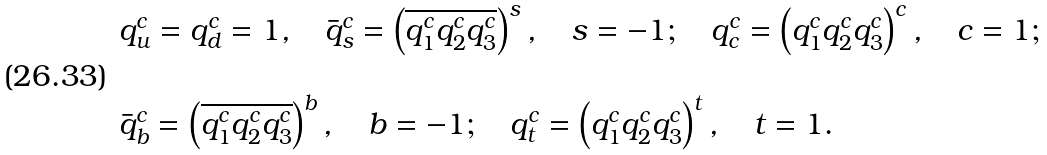<formula> <loc_0><loc_0><loc_500><loc_500>\begin{array} { l } q ^ { c } _ { u } = q ^ { c } _ { d } = 1 , \quad \bar { q } ^ { c } _ { s } = \left ( \overline { q _ { 1 } ^ { c } q _ { 2 } ^ { c } q _ { 3 } ^ { c } } \right ) ^ { s } , \quad s = - 1 ; \quad q ^ { c } _ { c } = \left ( q _ { 1 } ^ { c } q _ { 2 } ^ { c } q _ { 3 } ^ { c } \right ) ^ { c } , \quad c = 1 ; \\ \\ \bar { q } _ { b } ^ { c } = \left ( \overline { q _ { 1 } ^ { c } q _ { 2 } ^ { c } q _ { 3 } ^ { c } } \right ) ^ { b } , \quad b = - 1 ; \quad q _ { t } ^ { c } = \left ( q _ { 1 } ^ { c } q _ { 2 } ^ { c } q _ { 3 } ^ { c } \right ) ^ { t } , \quad t = 1 . \end{array}</formula> 